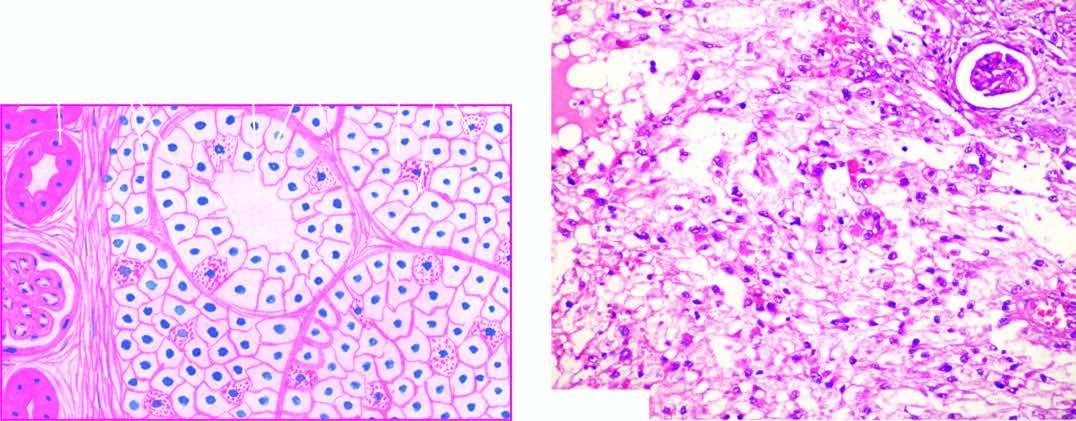s the deposition composed of fine and delicate fibrous tissue?
Answer the question using a single word or phrase. No 